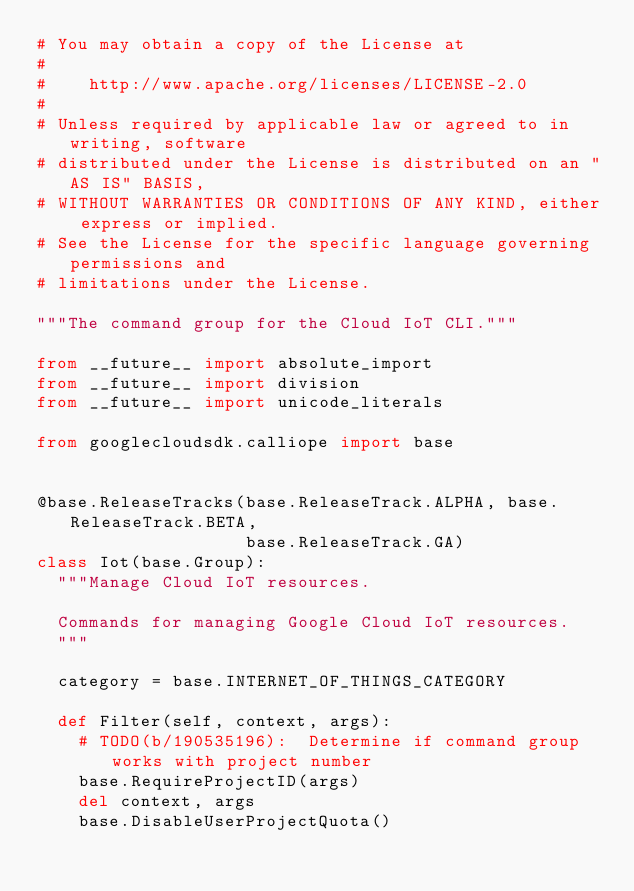Convert code to text. <code><loc_0><loc_0><loc_500><loc_500><_Python_># You may obtain a copy of the License at
#
#    http://www.apache.org/licenses/LICENSE-2.0
#
# Unless required by applicable law or agreed to in writing, software
# distributed under the License is distributed on an "AS IS" BASIS,
# WITHOUT WARRANTIES OR CONDITIONS OF ANY KIND, either express or implied.
# See the License for the specific language governing permissions and
# limitations under the License.

"""The command group for the Cloud IoT CLI."""

from __future__ import absolute_import
from __future__ import division
from __future__ import unicode_literals

from googlecloudsdk.calliope import base


@base.ReleaseTracks(base.ReleaseTrack.ALPHA, base.ReleaseTrack.BETA,
                    base.ReleaseTrack.GA)
class Iot(base.Group):
  """Manage Cloud IoT resources.

  Commands for managing Google Cloud IoT resources.
  """

  category = base.INTERNET_OF_THINGS_CATEGORY

  def Filter(self, context, args):
    # TODO(b/190535196):  Determine if command group works with project number
    base.RequireProjectID(args)
    del context, args
    base.DisableUserProjectQuota()
</code> 